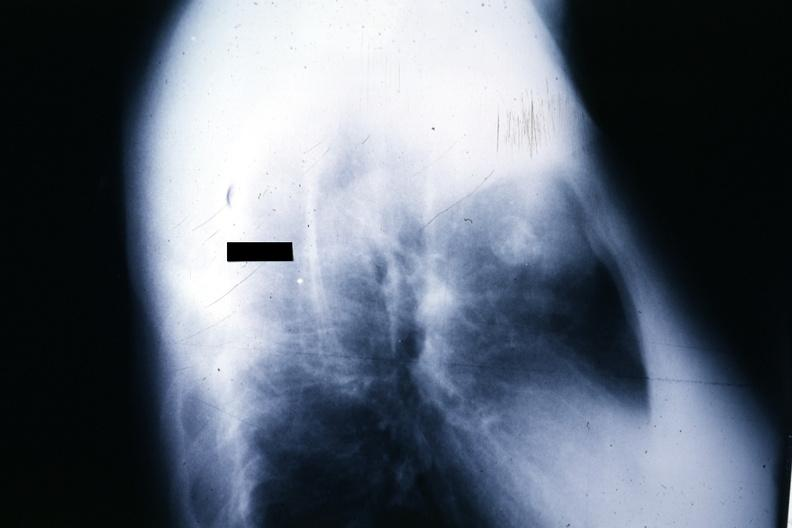s hematologic present?
Answer the question using a single word or phrase. Yes 